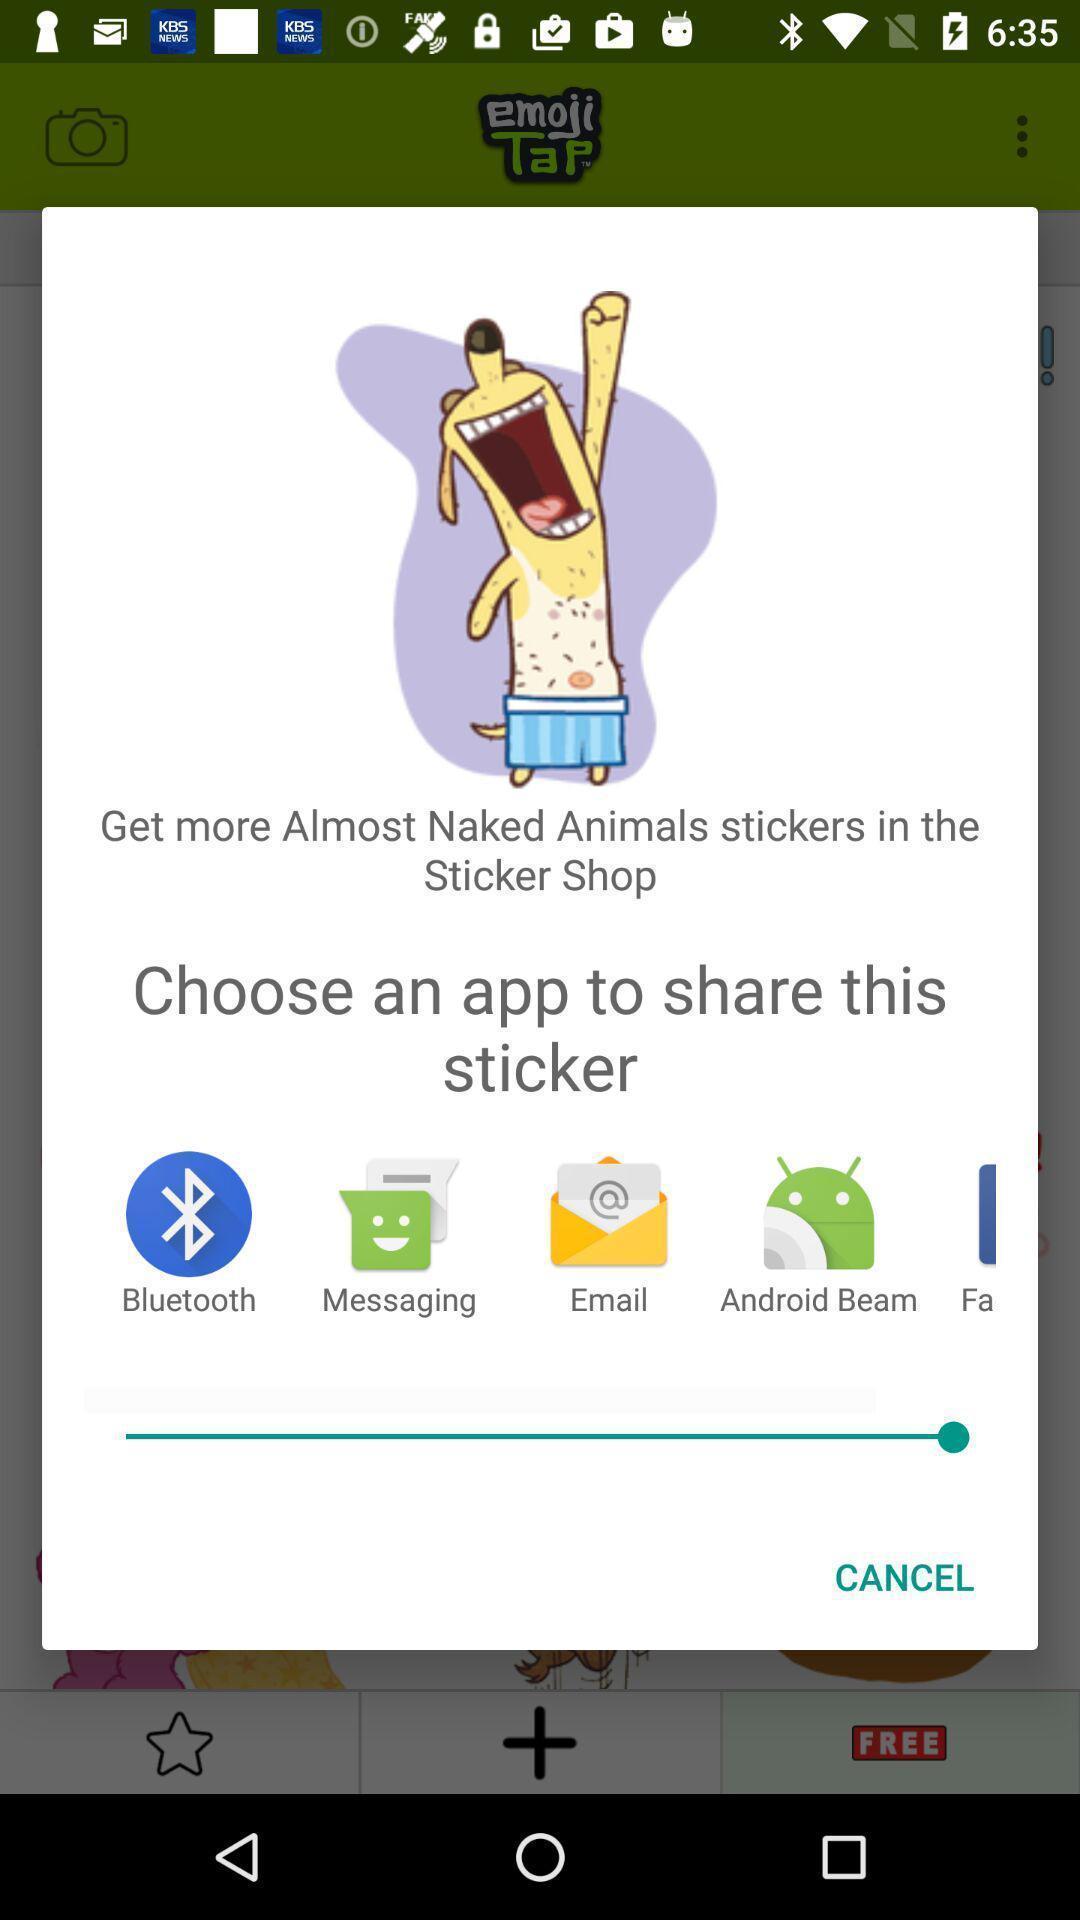Provide a detailed account of this screenshot. Popup of applications to share the information. 